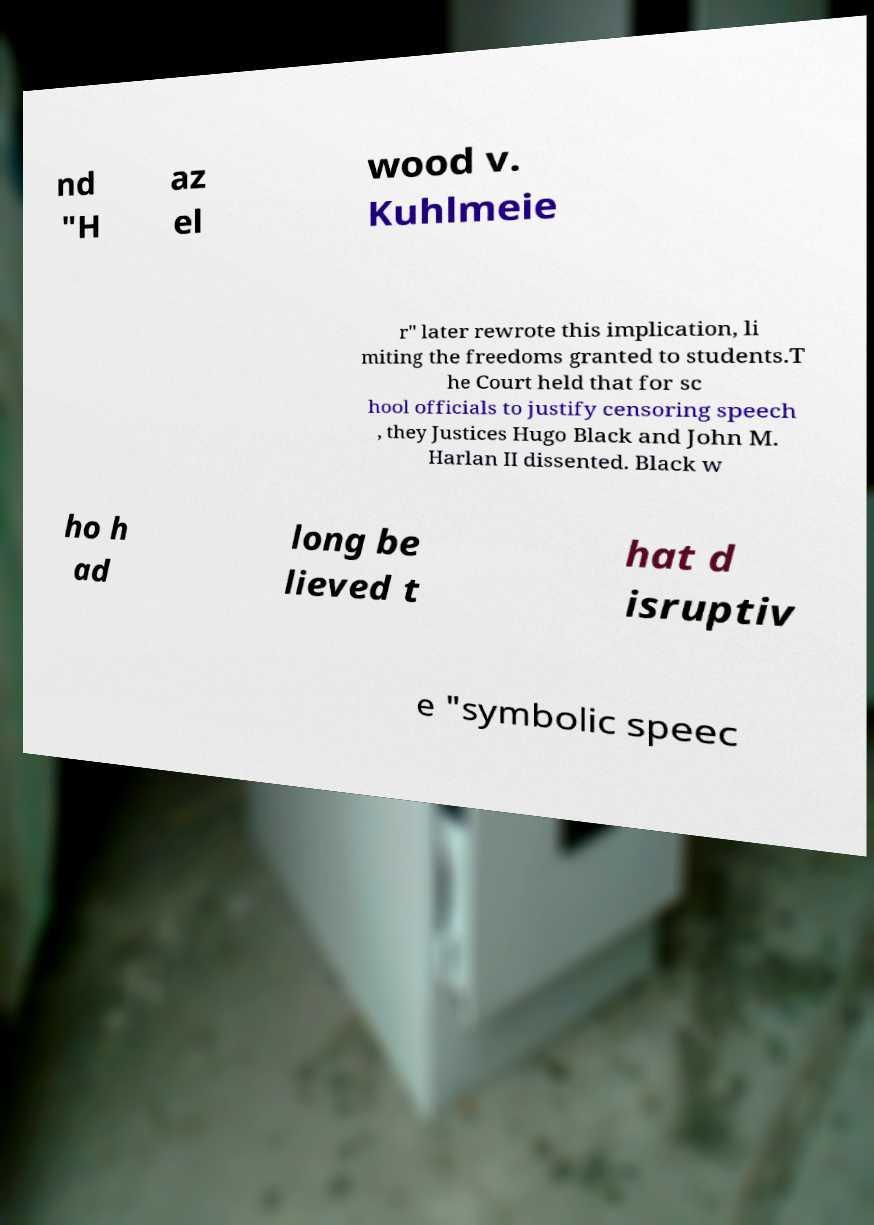Could you extract and type out the text from this image? nd "H az el wood v. Kuhlmeie r" later rewrote this implication, li miting the freedoms granted to students.T he Court held that for sc hool officials to justify censoring speech , they Justices Hugo Black and John M. Harlan II dissented. Black w ho h ad long be lieved t hat d isruptiv e "symbolic speec 